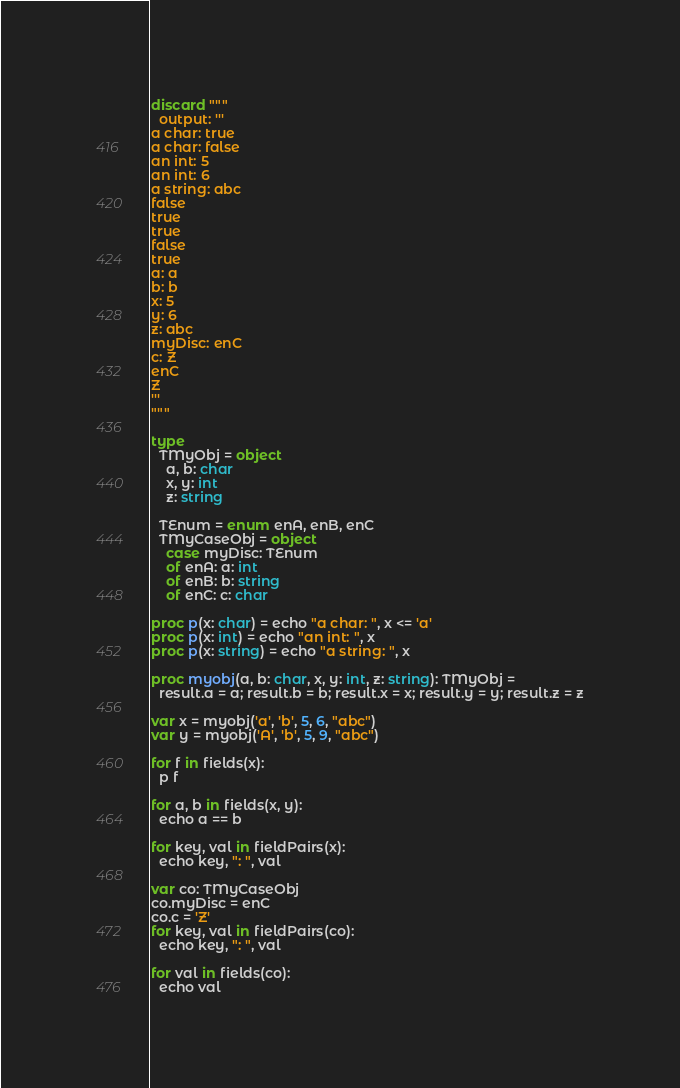<code> <loc_0><loc_0><loc_500><loc_500><_Nim_>discard """
  output: '''
a char: true
a char: false
an int: 5
an int: 6
a string: abc
false
true
true
false
true
a: a
b: b
x: 5
y: 6
z: abc
myDisc: enC
c: Z
enC
Z
'''
"""

type
  TMyObj = object
    a, b: char
    x, y: int
    z: string
    
  TEnum = enum enA, enB, enC
  TMyCaseObj = object
    case myDisc: TEnum
    of enA: a: int
    of enB: b: string
    of enC: c: char

proc p(x: char) = echo "a char: ", x <= 'a'
proc p(x: int) = echo "an int: ", x
proc p(x: string) = echo "a string: ", x

proc myobj(a, b: char, x, y: int, z: string): TMyObj =
  result.a = a; result.b = b; result.x = x; result.y = y; result.z = z

var x = myobj('a', 'b', 5, 6, "abc")
var y = myobj('A', 'b', 5, 9, "abc")

for f in fields(x): 
  p f

for a, b in fields(x, y):
  echo a == b

for key, val in fieldPairs(x):
  echo key, ": ", val

var co: TMyCaseObj
co.myDisc = enC
co.c = 'Z'
for key, val in fieldPairs(co):
  echo key, ": ", val

for val in fields(co):
  echo val
</code> 